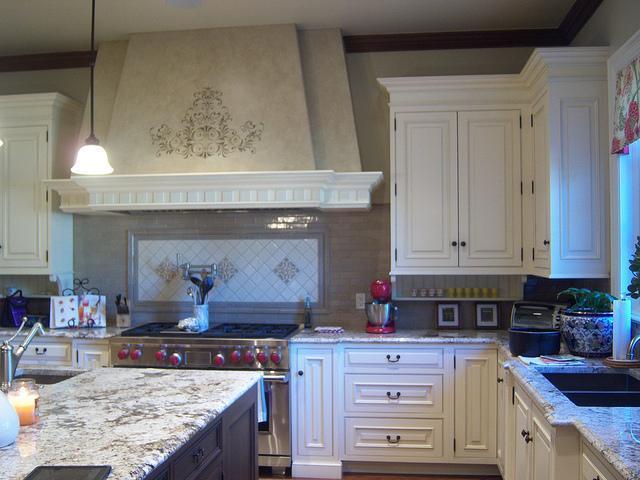How many dining tables are visible?
Give a very brief answer. 1. 